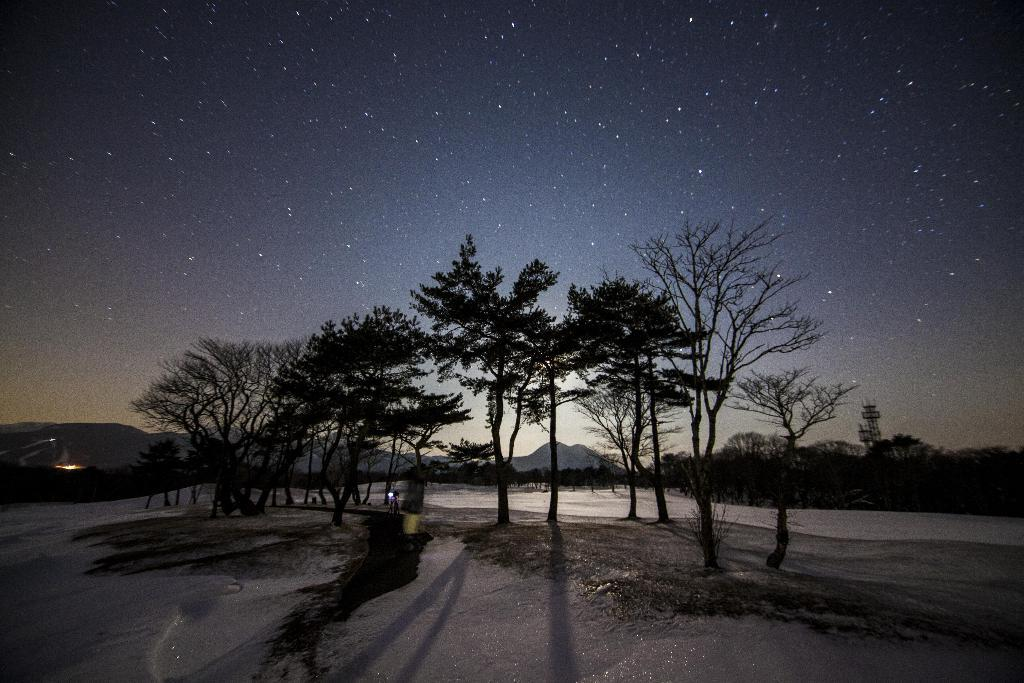What type of vegetation can be seen in the image? There are trees in the image. What can be seen in the sky in the image? Stars are visible in the sky. What type of landscape features are present in the background of the image? There are hills and towers in the background of the image. How many bushes are present in the image? There is no mention of bushes in the provided facts, so we cannot determine the number of bushes in the image. What type of agreement is being made in the image? There is no indication of any agreement being made in the image, as it primarily features trees, stars, hills, and towers. 